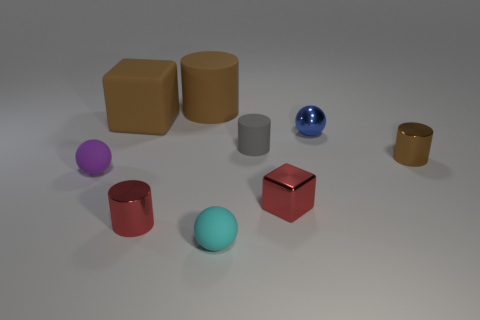Subtract all red cylinders. Subtract all red cubes. How many cylinders are left? 3 Add 1 small blue shiny objects. How many objects exist? 10 Subtract all cylinders. How many objects are left? 5 Subtract all large brown rubber objects. Subtract all big matte things. How many objects are left? 5 Add 1 red metallic blocks. How many red metallic blocks are left? 2 Add 6 small red metal things. How many small red metal things exist? 8 Subtract 1 red cylinders. How many objects are left? 8 